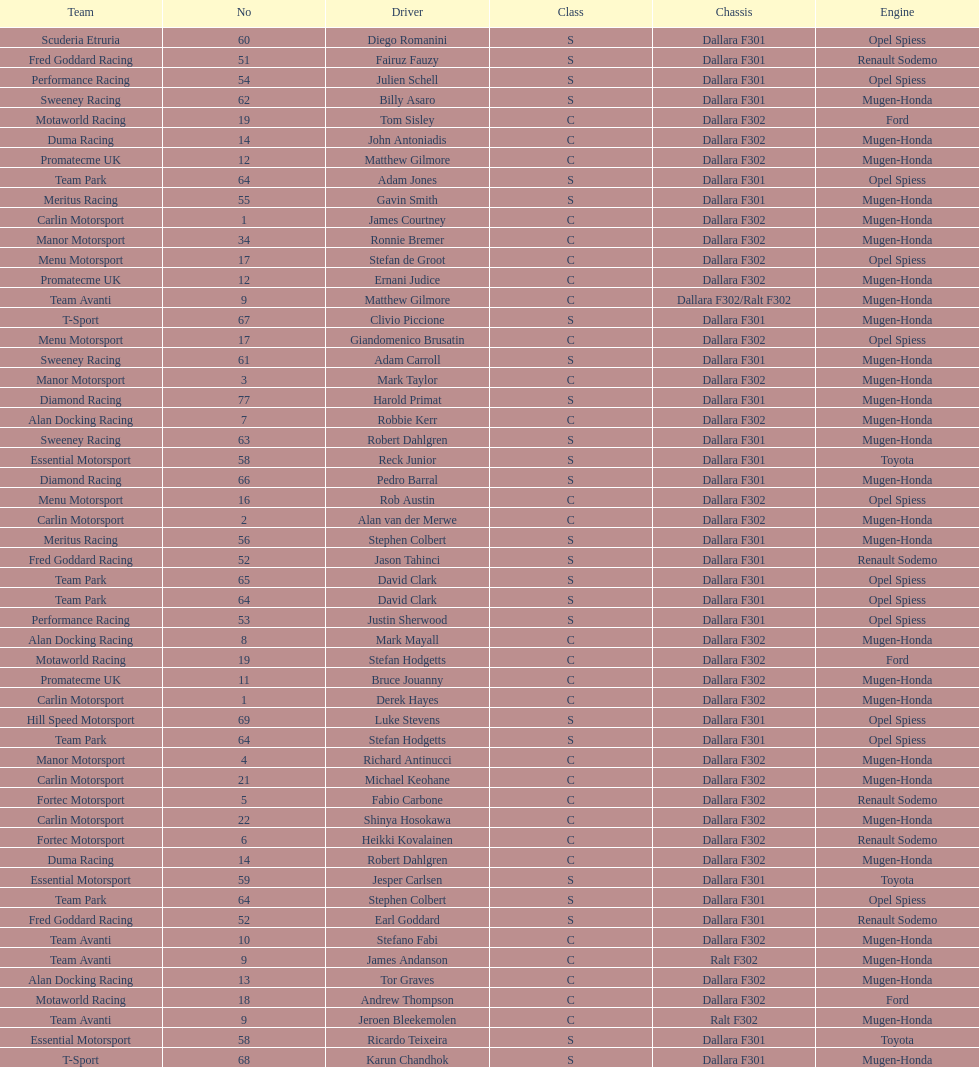How many class s (scholarship) teams are on the chart? 19. 